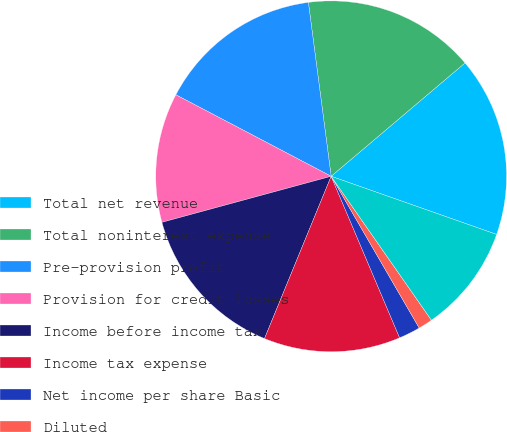<chart> <loc_0><loc_0><loc_500><loc_500><pie_chart><fcel>Total net revenue<fcel>Total noninterest expense<fcel>Pre-provision profit<fcel>Provision for credit losses<fcel>Income before income tax<fcel>Income tax expense<fcel>Net income per share Basic<fcel>Diluted<fcel>Cash dividends declared per<fcel>Book value per share<nl><fcel>16.56%<fcel>15.89%<fcel>15.23%<fcel>11.92%<fcel>14.57%<fcel>12.58%<fcel>1.99%<fcel>1.32%<fcel>0.0%<fcel>9.93%<nl></chart> 